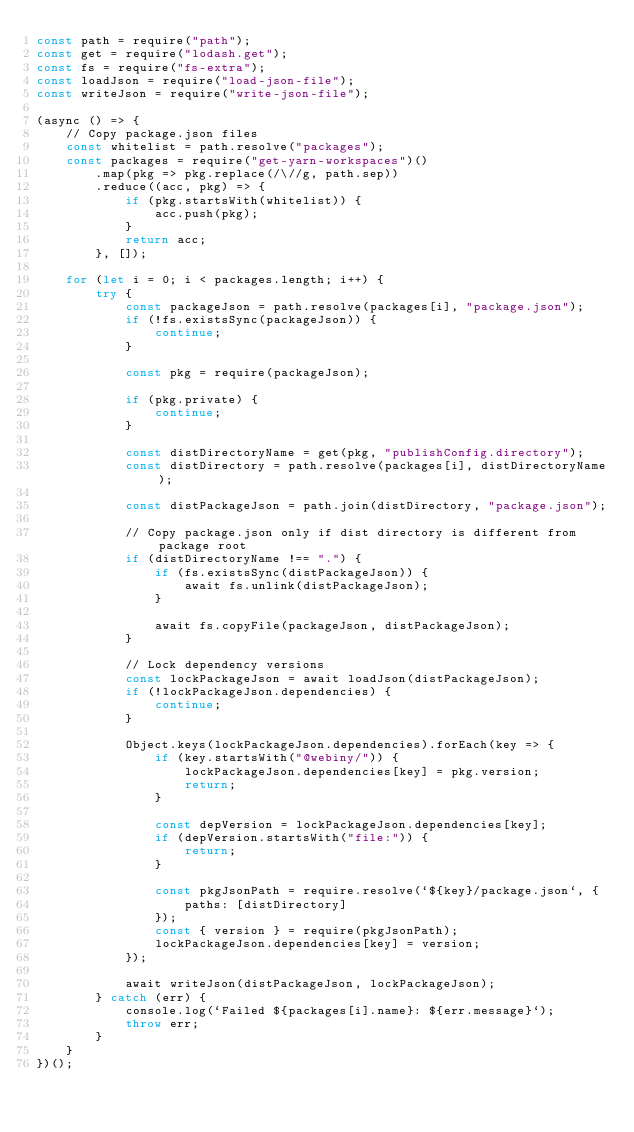Convert code to text. <code><loc_0><loc_0><loc_500><loc_500><_JavaScript_>const path = require("path");
const get = require("lodash.get");
const fs = require("fs-extra");
const loadJson = require("load-json-file");
const writeJson = require("write-json-file");

(async () => {
    // Copy package.json files
    const whitelist = path.resolve("packages");
    const packages = require("get-yarn-workspaces")()
        .map(pkg => pkg.replace(/\//g, path.sep))
        .reduce((acc, pkg) => {
            if (pkg.startsWith(whitelist)) {
                acc.push(pkg);
            }
            return acc;
        }, []);

    for (let i = 0; i < packages.length; i++) {
        try {
            const packageJson = path.resolve(packages[i], "package.json");
            if (!fs.existsSync(packageJson)) {
                continue;
            }

            const pkg = require(packageJson);

            if (pkg.private) {
                continue;
            }

            const distDirectoryName = get(pkg, "publishConfig.directory");
            const distDirectory = path.resolve(packages[i], distDirectoryName);

            const distPackageJson = path.join(distDirectory, "package.json");

            // Copy package.json only if dist directory is different from package root
            if (distDirectoryName !== ".") {
                if (fs.existsSync(distPackageJson)) {
                    await fs.unlink(distPackageJson);
                }

                await fs.copyFile(packageJson, distPackageJson);
            }

            // Lock dependency versions
            const lockPackageJson = await loadJson(distPackageJson);
            if (!lockPackageJson.dependencies) {
                continue;
            }

            Object.keys(lockPackageJson.dependencies).forEach(key => {
                if (key.startsWith("@webiny/")) {
                    lockPackageJson.dependencies[key] = pkg.version;
                    return;
                }

                const depVersion = lockPackageJson.dependencies[key];
                if (depVersion.startsWith("file:")) {
                    return;
                }

                const pkgJsonPath = require.resolve(`${key}/package.json`, {
                    paths: [distDirectory]
                });
                const { version } = require(pkgJsonPath);
                lockPackageJson.dependencies[key] = version;
            });

            await writeJson(distPackageJson, lockPackageJson);
        } catch (err) {
            console.log(`Failed ${packages[i].name}: ${err.message}`);
            throw err;
        }
    }
})();
</code> 